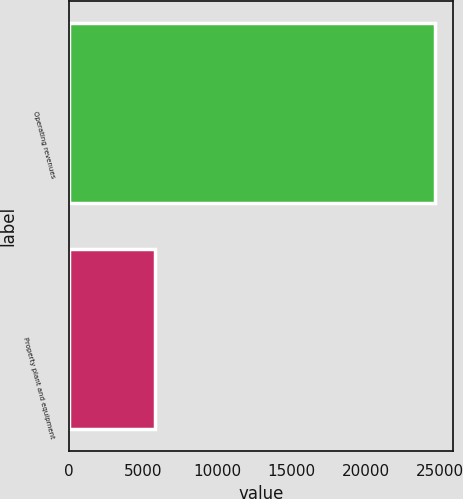Convert chart to OTSL. <chart><loc_0><loc_0><loc_500><loc_500><bar_chart><fcel>Operating revenues<fcel>Property plant and equipment<nl><fcel>24611<fcel>5792<nl></chart> 